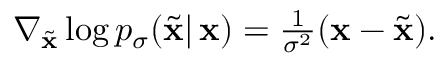<formula> <loc_0><loc_0><loc_500><loc_500>\begin{array} { r } { \nabla _ { \tilde { x } } \log p _ { \sigma } ( \tilde { x } | \, x ) = \frac { 1 } { \sigma ^ { 2 } } ( x - \tilde { x } ) . } \end{array}</formula> 